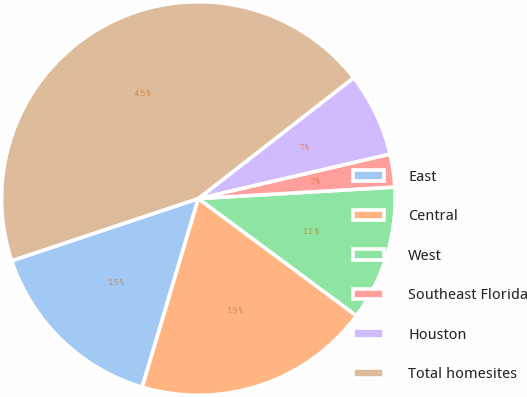Convert chart. <chart><loc_0><loc_0><loc_500><loc_500><pie_chart><fcel>East<fcel>Central<fcel>West<fcel>Southeast Florida<fcel>Houston<fcel>Total homesites<nl><fcel>15.27%<fcel>19.46%<fcel>11.08%<fcel>2.7%<fcel>6.89%<fcel>44.6%<nl></chart> 